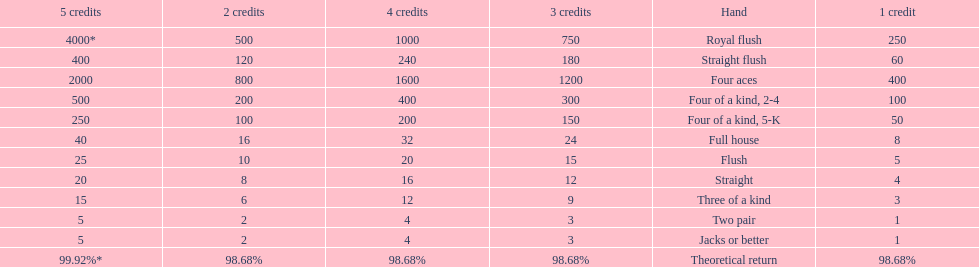What's the best type of four of a kind to win? Four of a kind, 2-4. 